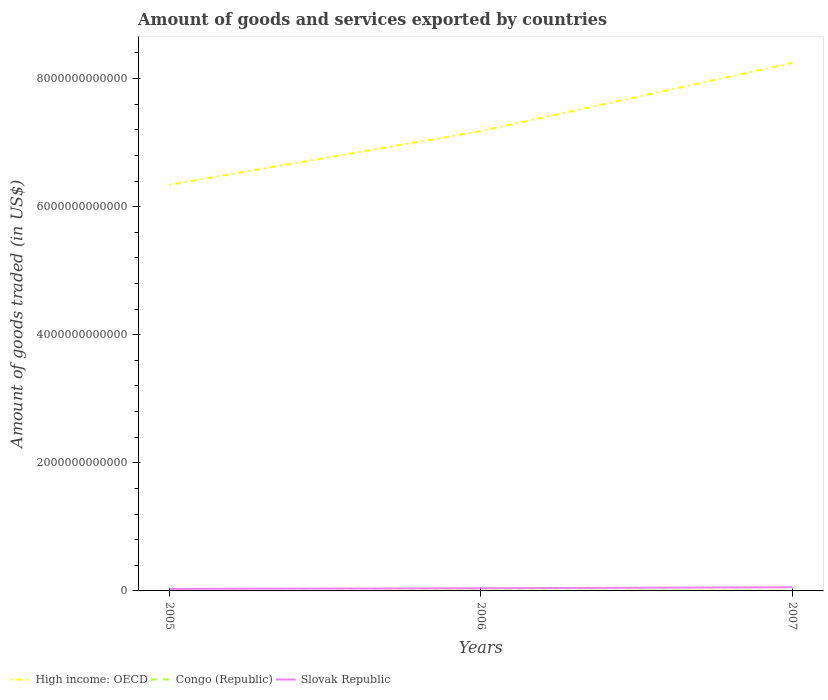Is the number of lines equal to the number of legend labels?
Keep it short and to the point. Yes. Across all years, what is the maximum total amount of goods and services exported in Slovak Republic?
Give a very brief answer. 3.18e+1. In which year was the total amount of goods and services exported in Slovak Republic maximum?
Provide a succinct answer. 2005. What is the total total amount of goods and services exported in High income: OECD in the graph?
Provide a succinct answer. -1.90e+12. What is the difference between the highest and the second highest total amount of goods and services exported in High income: OECD?
Offer a terse response. 1.90e+12. Is the total amount of goods and services exported in Congo (Republic) strictly greater than the total amount of goods and services exported in Slovak Republic over the years?
Make the answer very short. Yes. What is the difference between two consecutive major ticks on the Y-axis?
Give a very brief answer. 2.00e+12. Are the values on the major ticks of Y-axis written in scientific E-notation?
Ensure brevity in your answer.  No. Does the graph contain any zero values?
Offer a terse response. No. Does the graph contain grids?
Your answer should be very brief. No. How many legend labels are there?
Provide a succinct answer. 3. What is the title of the graph?
Keep it short and to the point. Amount of goods and services exported by countries. Does "Faeroe Islands" appear as one of the legend labels in the graph?
Offer a very short reply. No. What is the label or title of the Y-axis?
Give a very brief answer. Amount of goods traded (in US$). What is the Amount of goods traded (in US$) of High income: OECD in 2005?
Keep it short and to the point. 6.34e+12. What is the Amount of goods traded (in US$) in Congo (Republic) in 2005?
Give a very brief answer. 4.75e+09. What is the Amount of goods traded (in US$) of Slovak Republic in 2005?
Ensure brevity in your answer.  3.18e+1. What is the Amount of goods traded (in US$) of High income: OECD in 2006?
Make the answer very short. 7.18e+12. What is the Amount of goods traded (in US$) in Congo (Republic) in 2006?
Ensure brevity in your answer.  6.07e+09. What is the Amount of goods traded (in US$) of Slovak Republic in 2006?
Make the answer very short. 4.17e+1. What is the Amount of goods traded (in US$) of High income: OECD in 2007?
Give a very brief answer. 8.24e+12. What is the Amount of goods traded (in US$) in Congo (Republic) in 2007?
Offer a very short reply. 5.81e+09. What is the Amount of goods traded (in US$) of Slovak Republic in 2007?
Your answer should be very brief. 5.78e+1. Across all years, what is the maximum Amount of goods traded (in US$) in High income: OECD?
Offer a terse response. 8.24e+12. Across all years, what is the maximum Amount of goods traded (in US$) of Congo (Republic)?
Provide a succinct answer. 6.07e+09. Across all years, what is the maximum Amount of goods traded (in US$) of Slovak Republic?
Offer a terse response. 5.78e+1. Across all years, what is the minimum Amount of goods traded (in US$) of High income: OECD?
Your response must be concise. 6.34e+12. Across all years, what is the minimum Amount of goods traded (in US$) in Congo (Republic)?
Your answer should be very brief. 4.75e+09. Across all years, what is the minimum Amount of goods traded (in US$) in Slovak Republic?
Make the answer very short. 3.18e+1. What is the total Amount of goods traded (in US$) of High income: OECD in the graph?
Provide a short and direct response. 2.18e+13. What is the total Amount of goods traded (in US$) in Congo (Republic) in the graph?
Make the answer very short. 1.66e+1. What is the total Amount of goods traded (in US$) in Slovak Republic in the graph?
Make the answer very short. 1.31e+11. What is the difference between the Amount of goods traded (in US$) in High income: OECD in 2005 and that in 2006?
Your answer should be compact. -8.38e+11. What is the difference between the Amount of goods traded (in US$) of Congo (Republic) in 2005 and that in 2006?
Offer a very short reply. -1.32e+09. What is the difference between the Amount of goods traded (in US$) in Slovak Republic in 2005 and that in 2006?
Make the answer very short. -9.86e+09. What is the difference between the Amount of goods traded (in US$) of High income: OECD in 2005 and that in 2007?
Provide a short and direct response. -1.90e+12. What is the difference between the Amount of goods traded (in US$) in Congo (Republic) in 2005 and that in 2007?
Your answer should be compact. -1.06e+09. What is the difference between the Amount of goods traded (in US$) of Slovak Republic in 2005 and that in 2007?
Keep it short and to the point. -2.59e+1. What is the difference between the Amount of goods traded (in US$) of High income: OECD in 2006 and that in 2007?
Offer a very short reply. -1.06e+12. What is the difference between the Amount of goods traded (in US$) in Congo (Republic) in 2006 and that in 2007?
Provide a short and direct response. 2.58e+08. What is the difference between the Amount of goods traded (in US$) of Slovak Republic in 2006 and that in 2007?
Provide a short and direct response. -1.61e+1. What is the difference between the Amount of goods traded (in US$) of High income: OECD in 2005 and the Amount of goods traded (in US$) of Congo (Republic) in 2006?
Keep it short and to the point. 6.34e+12. What is the difference between the Amount of goods traded (in US$) of High income: OECD in 2005 and the Amount of goods traded (in US$) of Slovak Republic in 2006?
Provide a short and direct response. 6.30e+12. What is the difference between the Amount of goods traded (in US$) in Congo (Republic) in 2005 and the Amount of goods traded (in US$) in Slovak Republic in 2006?
Give a very brief answer. -3.70e+1. What is the difference between the Amount of goods traded (in US$) of High income: OECD in 2005 and the Amount of goods traded (in US$) of Congo (Republic) in 2007?
Your answer should be very brief. 6.34e+12. What is the difference between the Amount of goods traded (in US$) in High income: OECD in 2005 and the Amount of goods traded (in US$) in Slovak Republic in 2007?
Your response must be concise. 6.28e+12. What is the difference between the Amount of goods traded (in US$) of Congo (Republic) in 2005 and the Amount of goods traded (in US$) of Slovak Republic in 2007?
Make the answer very short. -5.30e+1. What is the difference between the Amount of goods traded (in US$) in High income: OECD in 2006 and the Amount of goods traded (in US$) in Congo (Republic) in 2007?
Make the answer very short. 7.17e+12. What is the difference between the Amount of goods traded (in US$) of High income: OECD in 2006 and the Amount of goods traded (in US$) of Slovak Republic in 2007?
Keep it short and to the point. 7.12e+12. What is the difference between the Amount of goods traded (in US$) in Congo (Republic) in 2006 and the Amount of goods traded (in US$) in Slovak Republic in 2007?
Your answer should be very brief. -5.17e+1. What is the average Amount of goods traded (in US$) in High income: OECD per year?
Provide a succinct answer. 7.26e+12. What is the average Amount of goods traded (in US$) of Congo (Republic) per year?
Your answer should be compact. 5.54e+09. What is the average Amount of goods traded (in US$) in Slovak Republic per year?
Ensure brevity in your answer.  4.38e+1. In the year 2005, what is the difference between the Amount of goods traded (in US$) in High income: OECD and Amount of goods traded (in US$) in Congo (Republic)?
Your response must be concise. 6.34e+12. In the year 2005, what is the difference between the Amount of goods traded (in US$) in High income: OECD and Amount of goods traded (in US$) in Slovak Republic?
Keep it short and to the point. 6.31e+12. In the year 2005, what is the difference between the Amount of goods traded (in US$) in Congo (Republic) and Amount of goods traded (in US$) in Slovak Republic?
Offer a terse response. -2.71e+1. In the year 2006, what is the difference between the Amount of goods traded (in US$) in High income: OECD and Amount of goods traded (in US$) in Congo (Republic)?
Keep it short and to the point. 7.17e+12. In the year 2006, what is the difference between the Amount of goods traded (in US$) in High income: OECD and Amount of goods traded (in US$) in Slovak Republic?
Offer a very short reply. 7.14e+12. In the year 2006, what is the difference between the Amount of goods traded (in US$) in Congo (Republic) and Amount of goods traded (in US$) in Slovak Republic?
Ensure brevity in your answer.  -3.56e+1. In the year 2007, what is the difference between the Amount of goods traded (in US$) of High income: OECD and Amount of goods traded (in US$) of Congo (Republic)?
Ensure brevity in your answer.  8.24e+12. In the year 2007, what is the difference between the Amount of goods traded (in US$) in High income: OECD and Amount of goods traded (in US$) in Slovak Republic?
Provide a succinct answer. 8.19e+12. In the year 2007, what is the difference between the Amount of goods traded (in US$) in Congo (Republic) and Amount of goods traded (in US$) in Slovak Republic?
Offer a terse response. -5.20e+1. What is the ratio of the Amount of goods traded (in US$) of High income: OECD in 2005 to that in 2006?
Offer a very short reply. 0.88. What is the ratio of the Amount of goods traded (in US$) in Congo (Republic) in 2005 to that in 2006?
Your answer should be compact. 0.78. What is the ratio of the Amount of goods traded (in US$) in Slovak Republic in 2005 to that in 2006?
Your answer should be compact. 0.76. What is the ratio of the Amount of goods traded (in US$) in High income: OECD in 2005 to that in 2007?
Offer a terse response. 0.77. What is the ratio of the Amount of goods traded (in US$) of Congo (Republic) in 2005 to that in 2007?
Keep it short and to the point. 0.82. What is the ratio of the Amount of goods traded (in US$) in Slovak Republic in 2005 to that in 2007?
Your answer should be very brief. 0.55. What is the ratio of the Amount of goods traded (in US$) in High income: OECD in 2006 to that in 2007?
Your response must be concise. 0.87. What is the ratio of the Amount of goods traded (in US$) of Congo (Republic) in 2006 to that in 2007?
Your answer should be compact. 1.04. What is the ratio of the Amount of goods traded (in US$) in Slovak Republic in 2006 to that in 2007?
Keep it short and to the point. 0.72. What is the difference between the highest and the second highest Amount of goods traded (in US$) of High income: OECD?
Your answer should be compact. 1.06e+12. What is the difference between the highest and the second highest Amount of goods traded (in US$) in Congo (Republic)?
Keep it short and to the point. 2.58e+08. What is the difference between the highest and the second highest Amount of goods traded (in US$) of Slovak Republic?
Your response must be concise. 1.61e+1. What is the difference between the highest and the lowest Amount of goods traded (in US$) in High income: OECD?
Ensure brevity in your answer.  1.90e+12. What is the difference between the highest and the lowest Amount of goods traded (in US$) of Congo (Republic)?
Provide a succinct answer. 1.32e+09. What is the difference between the highest and the lowest Amount of goods traded (in US$) in Slovak Republic?
Give a very brief answer. 2.59e+1. 